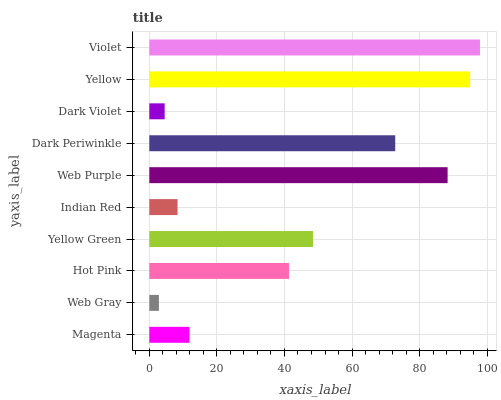Is Web Gray the minimum?
Answer yes or no. Yes. Is Violet the maximum?
Answer yes or no. Yes. Is Hot Pink the minimum?
Answer yes or no. No. Is Hot Pink the maximum?
Answer yes or no. No. Is Hot Pink greater than Web Gray?
Answer yes or no. Yes. Is Web Gray less than Hot Pink?
Answer yes or no. Yes. Is Web Gray greater than Hot Pink?
Answer yes or no. No. Is Hot Pink less than Web Gray?
Answer yes or no. No. Is Yellow Green the high median?
Answer yes or no. Yes. Is Hot Pink the low median?
Answer yes or no. Yes. Is Web Purple the high median?
Answer yes or no. No. Is Indian Red the low median?
Answer yes or no. No. 